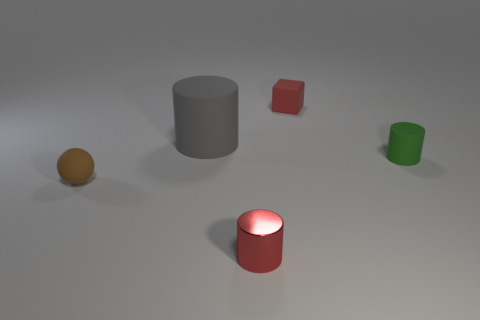Subtract all rubber cylinders. How many cylinders are left? 1 Subtract 2 cylinders. How many cylinders are left? 1 Add 3 large metallic cubes. How many objects exist? 8 Subtract all green cylinders. How many cylinders are left? 2 Subtract all cubes. How many objects are left? 4 Subtract all purple balls. Subtract all red cylinders. How many balls are left? 1 Subtract all brown balls. How many gray blocks are left? 0 Subtract all brown things. Subtract all tiny green matte objects. How many objects are left? 3 Add 1 large rubber cylinders. How many large rubber cylinders are left? 2 Add 2 gray cylinders. How many gray cylinders exist? 3 